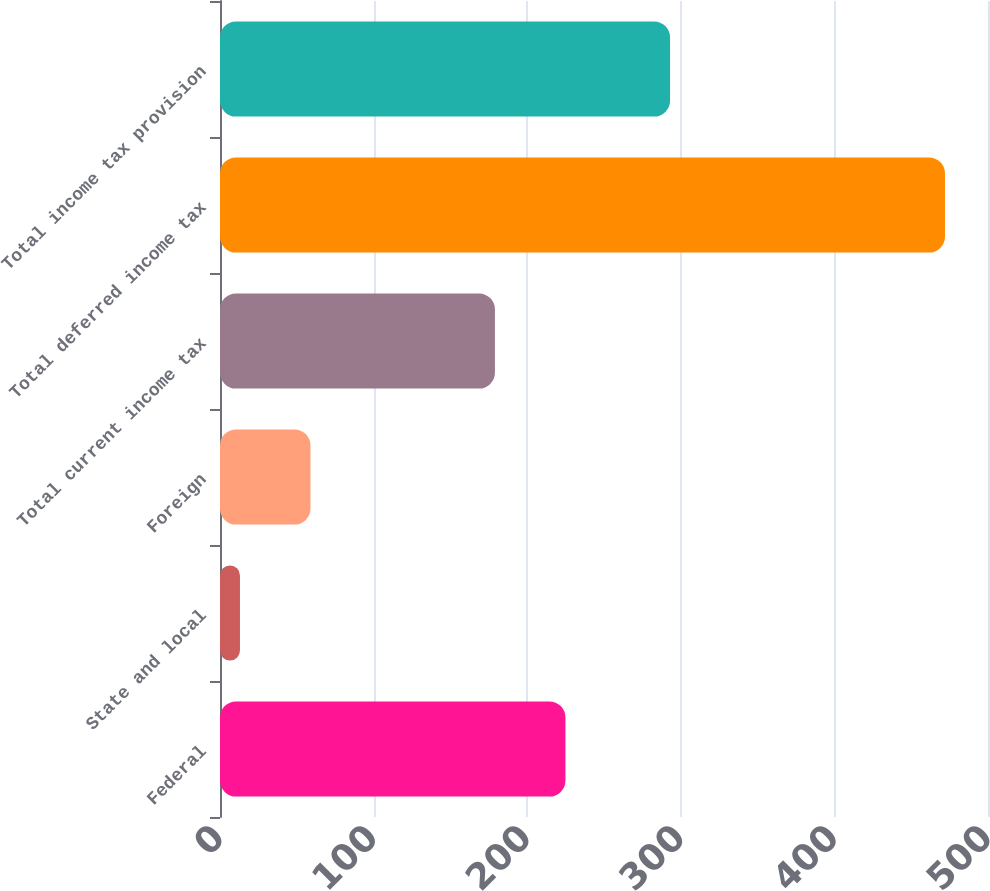Convert chart to OTSL. <chart><loc_0><loc_0><loc_500><loc_500><bar_chart><fcel>Federal<fcel>State and local<fcel>Foreign<fcel>Total current income tax<fcel>Total deferred income tax<fcel>Total income tax provision<nl><fcel>224.9<fcel>13<fcel>58.9<fcel>179<fcel>472<fcel>293<nl></chart> 